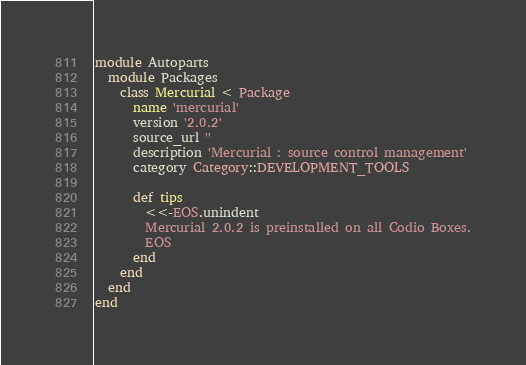<code> <loc_0><loc_0><loc_500><loc_500><_Ruby_>module Autoparts
  module Packages
    class Mercurial < Package
      name 'mercurial'
      version '2.0.2'
      source_url ''
      description 'Mercurial : source control management'
      category Category::DEVELOPMENT_TOOLS

      def tips
        <<-EOS.unindent
        Mercurial 2.0.2 is preinstalled on all Codio Boxes.
        EOS
      end
    end
  end
end
</code> 